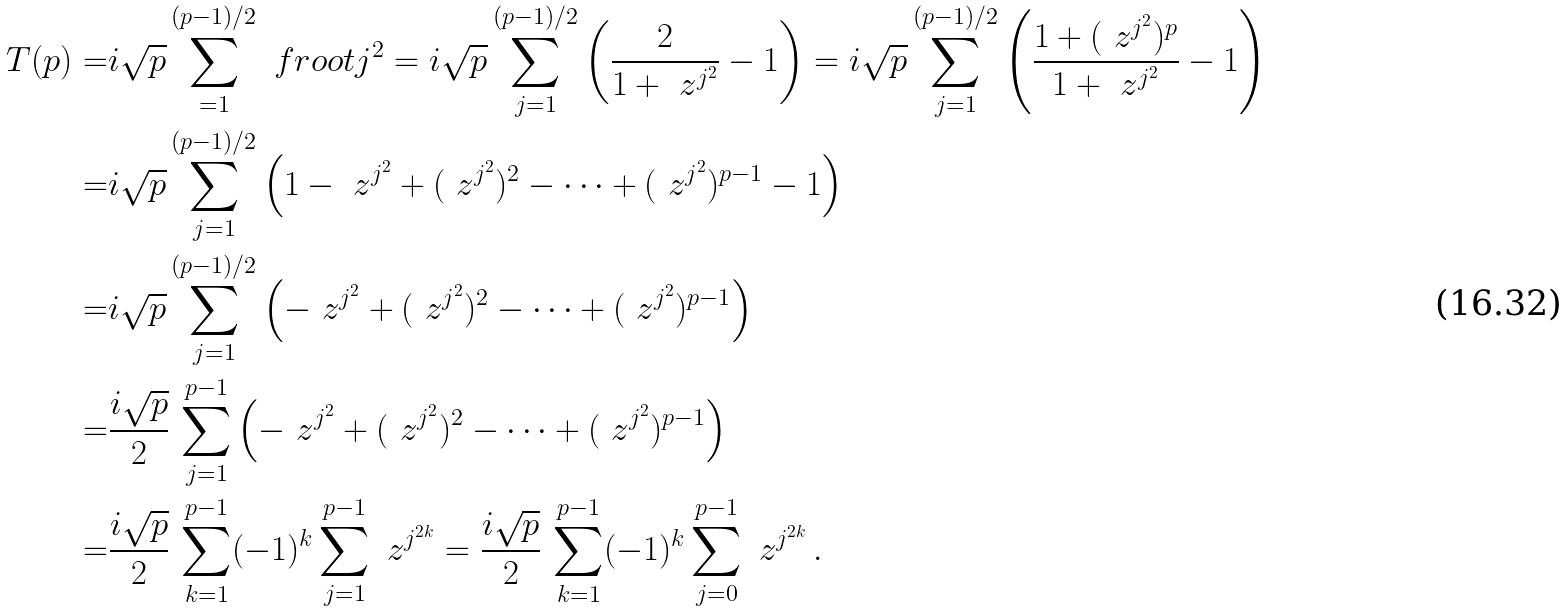<formula> <loc_0><loc_0><loc_500><loc_500>T ( p ) = & i \sqrt { p } \sum _ { = 1 } ^ { ( p - 1 ) / 2 } \ f r o o t { j ^ { 2 } } = i \sqrt { p } \sum _ { j = 1 } ^ { ( p - 1 ) / 2 } \left ( \frac { 2 } { 1 + \ z ^ { j ^ { 2 } } } - 1 \right ) = i \sqrt { p } \sum _ { j = 1 } ^ { ( p - 1 ) / 2 } \left ( \frac { 1 + ( \ z ^ { j ^ { 2 } } ) ^ { p } } { 1 + \ z ^ { j ^ { 2 } } } - 1 \right ) \\ = & i \sqrt { p } \sum _ { j = 1 } ^ { ( p - 1 ) / 2 } \left ( 1 - \ z ^ { j ^ { 2 } } + ( \ z ^ { j ^ { 2 } } ) ^ { 2 } - \cdots + ( \ z ^ { j ^ { 2 } } ) ^ { p - 1 } - 1 \right ) \\ = & i \sqrt { p } \sum _ { j = 1 } ^ { ( p - 1 ) / 2 } \left ( - \ z ^ { j ^ { 2 } } + ( \ z ^ { j ^ { 2 } } ) ^ { 2 } - \cdots + ( \ z ^ { j ^ { 2 } } ) ^ { p - 1 } \right ) \\ = & \frac { i \sqrt { p } } { 2 } \, \sum _ { j = 1 } ^ { p - 1 } \left ( - \ z ^ { j ^ { 2 } } + ( \ z ^ { j ^ { 2 } } ) ^ { 2 } - \cdots + ( \ z ^ { j ^ { 2 } } ) ^ { p - 1 } \right ) \\ = & \frac { i \sqrt { p } } { 2 } \, \sum _ { k = 1 } ^ { p - 1 } ( - 1 ) ^ { k } \sum _ { j = 1 } ^ { p - 1 } \ z ^ { j ^ { 2 k } } = \frac { i \sqrt { p } } { 2 } \, \sum _ { k = 1 } ^ { p - 1 } ( - 1 ) ^ { k } \sum _ { j = 0 } ^ { p - 1 } \ z ^ { j ^ { 2 k } } \, .</formula> 